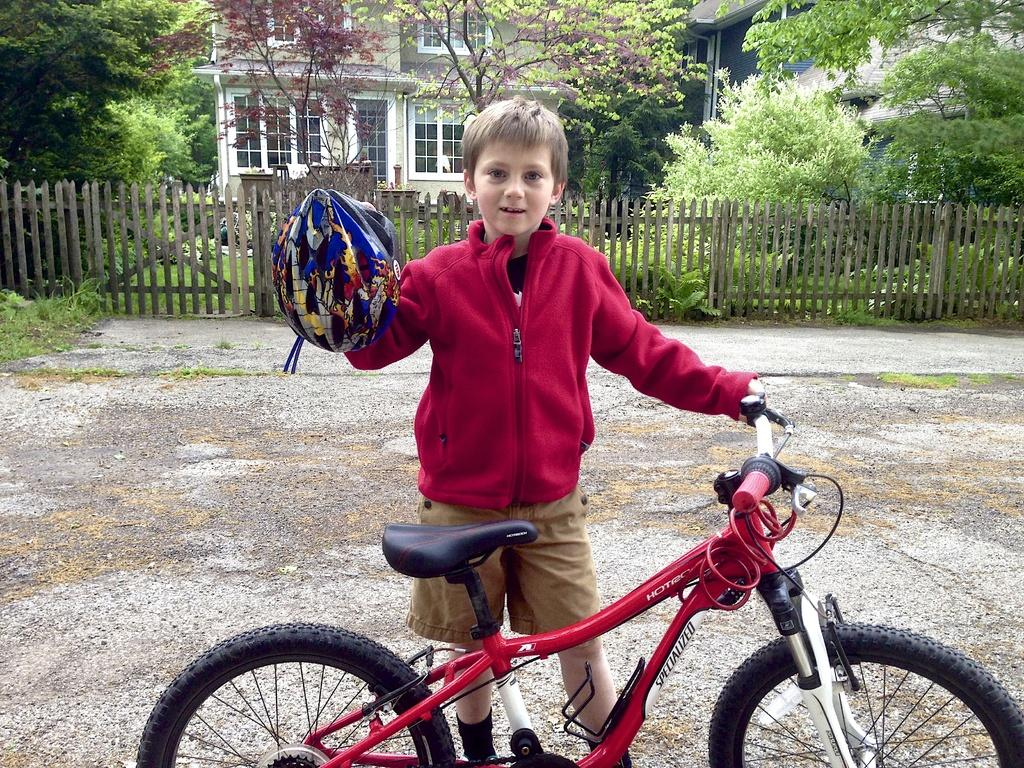What type of setting is shown in the image? The image depicts an open space. Can you describe the child in the image? There is a kid in the image, and they are wearing a red jacket. What is the kid holding in the image? The kid is holding a cycle. What can be seen in the background of the image? There is fencing, trees, and a house in the background. What type of locket is the kid wearing around their neck in the image? There is no locket visible around the kid's neck in the image. What type of wool is used to make the kid's red jacket? The provided facts do not mention the material used to make the kid's red jacket. 